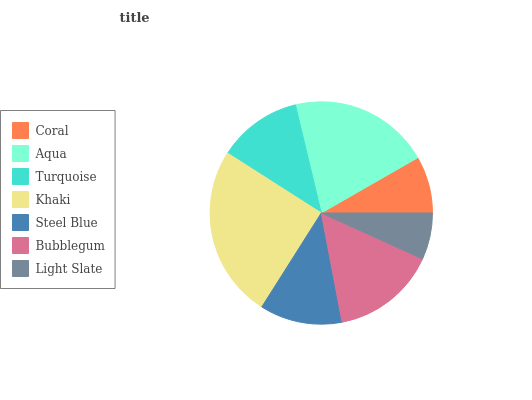Is Light Slate the minimum?
Answer yes or no. Yes. Is Khaki the maximum?
Answer yes or no. Yes. Is Aqua the minimum?
Answer yes or no. No. Is Aqua the maximum?
Answer yes or no. No. Is Aqua greater than Coral?
Answer yes or no. Yes. Is Coral less than Aqua?
Answer yes or no. Yes. Is Coral greater than Aqua?
Answer yes or no. No. Is Aqua less than Coral?
Answer yes or no. No. Is Turquoise the high median?
Answer yes or no. Yes. Is Turquoise the low median?
Answer yes or no. Yes. Is Coral the high median?
Answer yes or no. No. Is Bubblegum the low median?
Answer yes or no. No. 